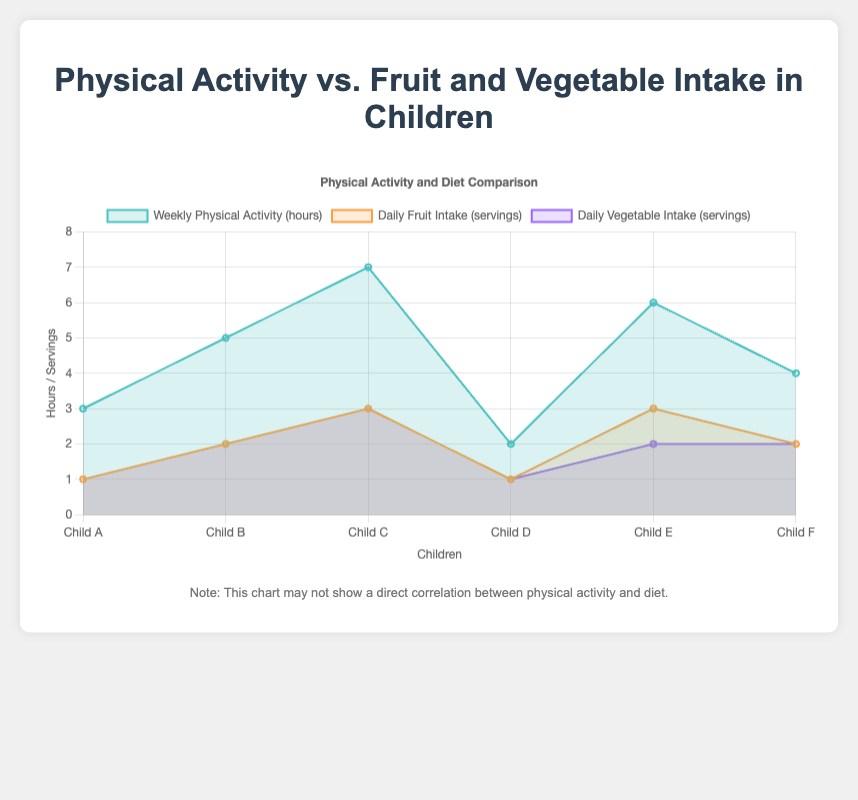What does the title of the chart indicate? The title "Physical Activity vs. Fruit and Vegetable Intake in Children" sets the context of the chart, showing that it compares the weekly hours spent on physical activities by children against their daily servings of fruits and vegetables.
Answer: Physical Activity vs. Fruit and Vegetable Intake in Children How many data lines are there on the chart? There are three datasets on the chart, corresponding to weekly physical activity, daily fruit intake, and daily vegetable intake.
Answer: Three Which child has the lowest weekly physical activity? The chart indicates that "Child D" has the lowest weekly physical activity with 2 hours.
Answer: Child D Which child has the highest daily fruit intake? "Child C" has the highest daily fruit intake with 3 servings per day, as shown in the chart.
Answer: Child C Do any children have equal servings of daily fruit and vegetable intake? The chart shows that "Child A", "Child B", "Child D", and "Child F" have equal daily servings of fruits and vegetables.
Answer: Child A, Child B, Child D, Child F What is the total weekly physical activity for all children combined? By adding the weekly physical activity hours: 3 + 5 + 7 + 2 + 6 + 4 = 27 hours.
Answer: 27 hours Which child has a higher daily vegetable intake than their daily fruit intake? The chart indicates that none of the children have a higher daily vegetable intake than their daily fruit intake.
Answer: None Compare the average daily fruit intake to the average daily vegetable intake Average daily fruit intake: (1 + 2 + 3 + 1 + 3 + 2) / 6 = 2; Average daily vegetable intake: (1 + 2 + 3 + 1 + 2 + 2) / 6 = 1.833; Thus the average fruit intake is slightly higher.
Answer: Fruit: 2, Vegetable: 1.833 In terms of physical activity, which child shows the most significant difference compared to their daily fruit intake? "Child C" has the most significant difference with 7 hours of physical activity and 3 servings of fruit intake, resulting in a difference of 4.
Answer: Child C When adding one serving of daily fruit intake and one hour of weekly physical activity to each child, which child would have the most hours of physical activity? Adding one hour to each, "Child C" would have 7+1=8 hours, the highest among all children.
Answer: Child C Is there a child with an equal or higher weekly physical activity than their combined fruit and vegetable intake? By examining the chart, "Child C" has 7 hours of physical activity and a combined intake of 6 servings (3 fruits + 3 vegetables), meeting the condition.
Answer: Child C 